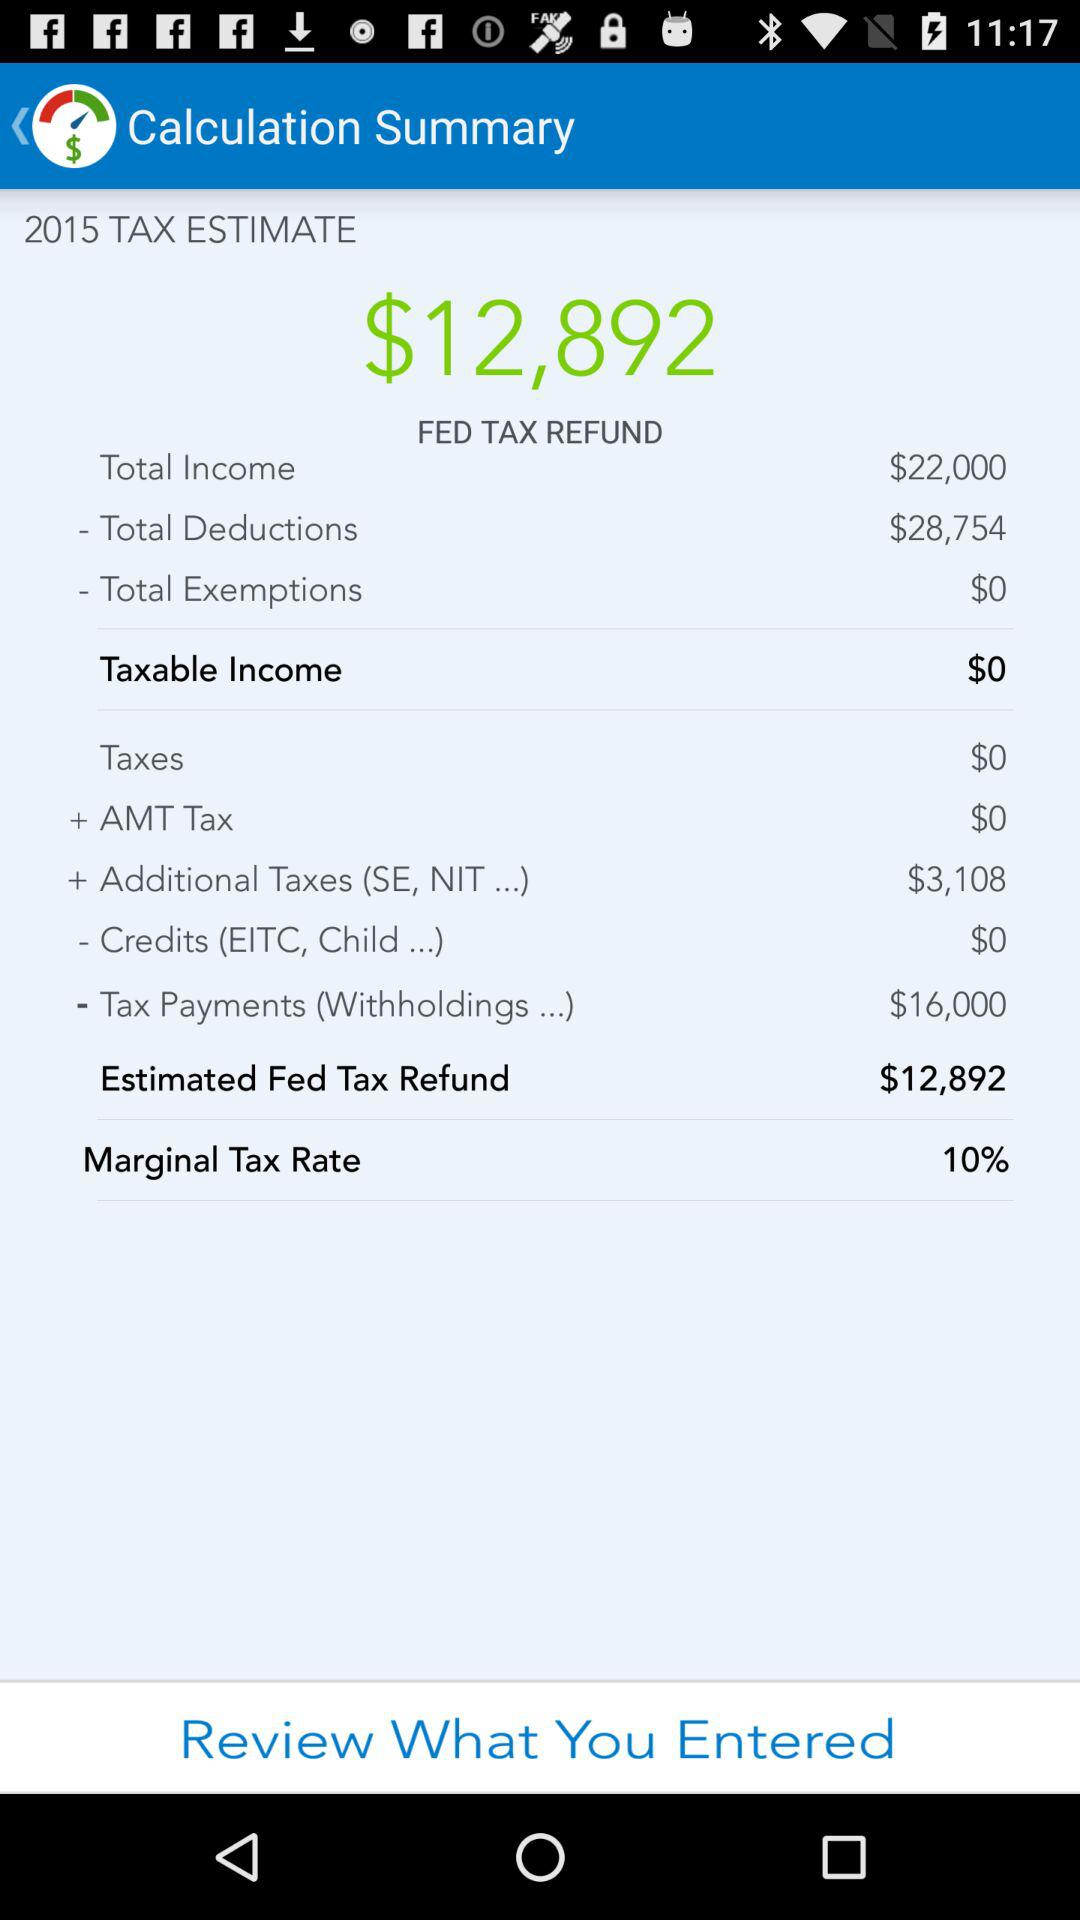What are the "Total Exemptions"? The total exemptions are $0. 